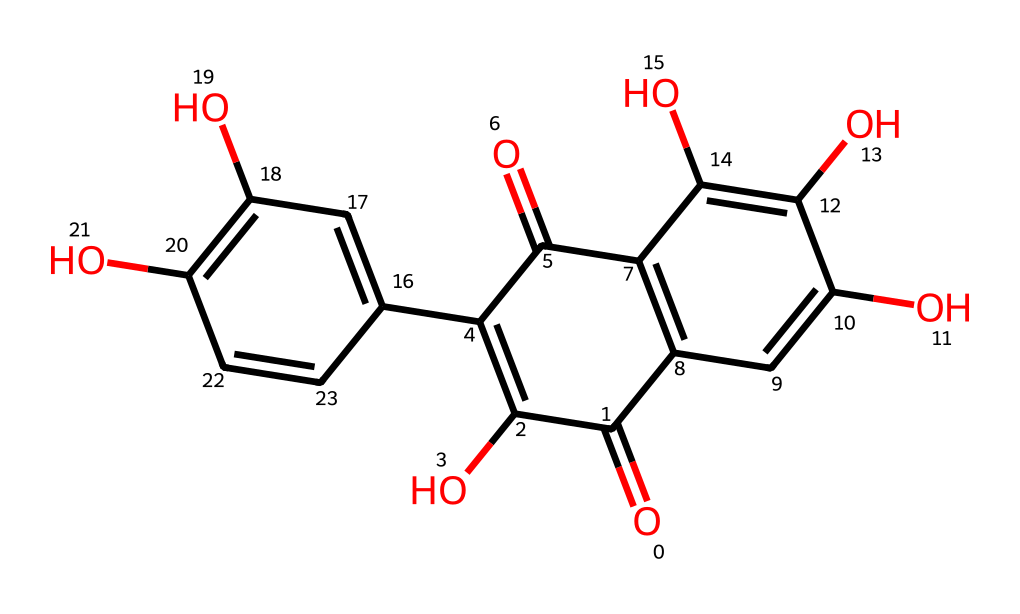What is the molecular formula of quercetin? The SMILES representation allows us to identify the number of each type of atom present. By analyzing the structure, we can count 15 carbons, 10 hydrogens, and 7 oxygens, leading us to the formula C15H10O7.
Answer: C15H10O7 How many hydroxyl groups are present in quercetin? By examining the structure, we can identify the presence of hydroxyl (-OH) groups. In the quercetin structure, there are 5 hydroxyl groups attached to the aromatic rings.
Answer: 5 What type of chemical is quercetin classified as? Quercetin contains multiple -OH groups attached to aromatic rings, which classifies it as a flavonoid, a specific type of phenol.
Answer: flavonoid How many rings are present in the quercetin molecule? Looking at the structure, we can count three fused aromatic rings that make up the backbone of the quercetin molecule.
Answer: 3 What functional groups are found in this molecule? In quercetin, we can identify hydroxyl (-OH) groups and ketone (C=O) functionalities, which contribute to its chemical properties and antioxidant activity.
Answer: hydroxyl and ketone What property is primarily attributed to the presence of hydroxyl groups in quercetin? The hydroxyl groups in quercetin are responsible for its antioxidant properties, as they can donate hydrogen atoms to free radicals, thus neutralizing them.
Answer: antioxidant properties 